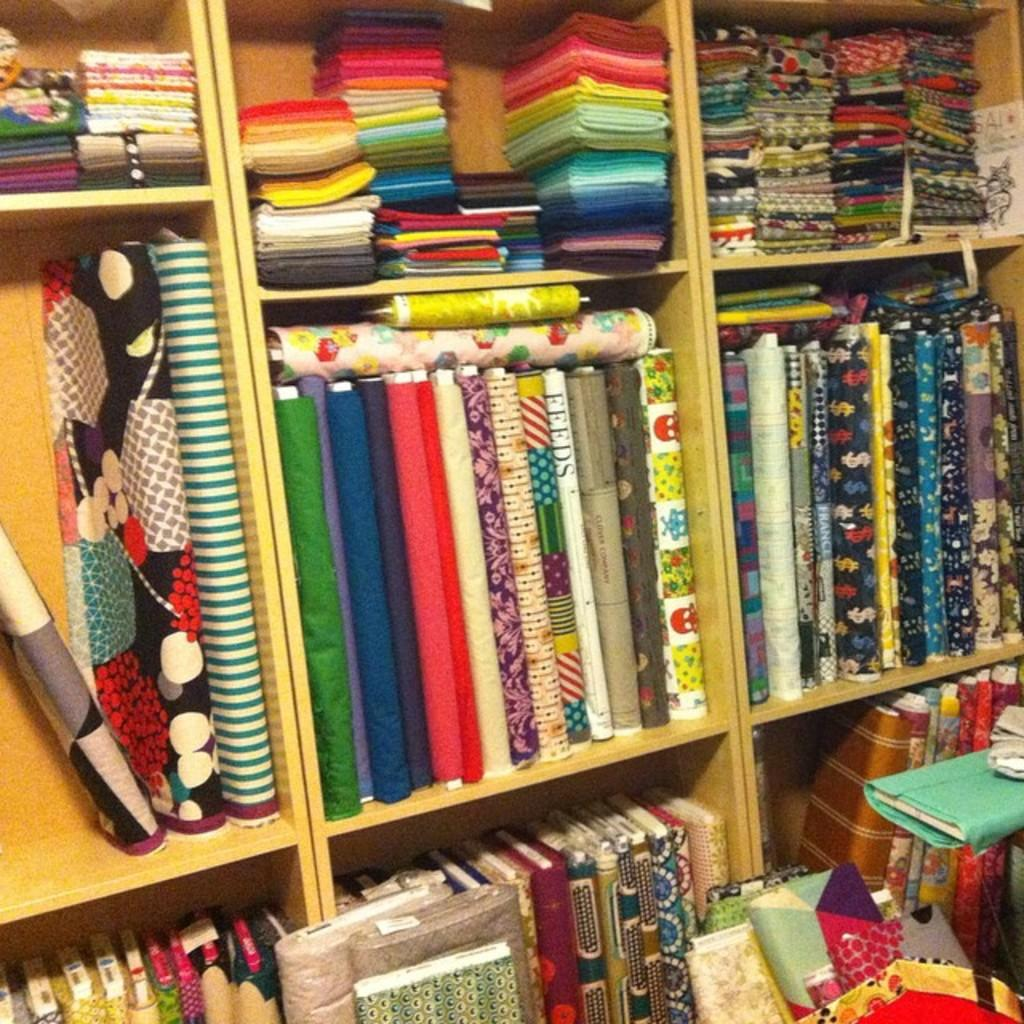What type of items can be seen in the image? There are clothes in different colors in the image. How are the clothes arranged in the image? The clothes are arranged on wooden shelves, and there are also clothes on the floor on the right side of the image. What type of insect can be seen crawling on the clothes in the image? There is no insect present in the image; it only features clothes arranged on wooden shelves and on the floor. 